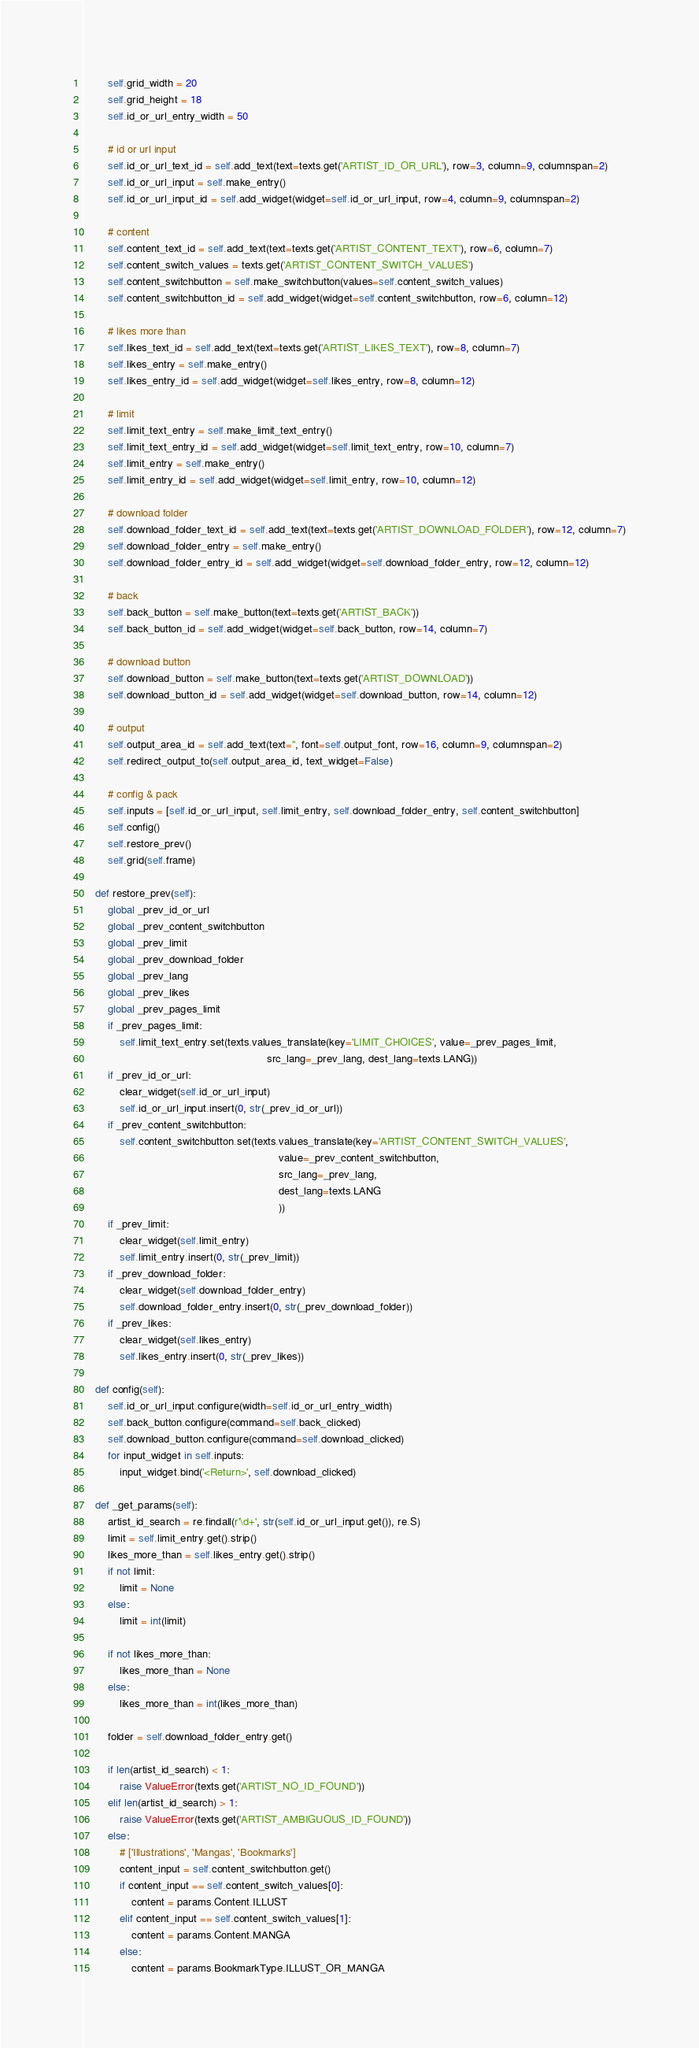<code> <loc_0><loc_0><loc_500><loc_500><_Python_>        self.grid_width = 20
        self.grid_height = 18
        self.id_or_url_entry_width = 50

        # id or url input
        self.id_or_url_text_id = self.add_text(text=texts.get('ARTIST_ID_OR_URL'), row=3, column=9, columnspan=2)
        self.id_or_url_input = self.make_entry()
        self.id_or_url_input_id = self.add_widget(widget=self.id_or_url_input, row=4, column=9, columnspan=2)

        # content
        self.content_text_id = self.add_text(text=texts.get('ARTIST_CONTENT_TEXT'), row=6, column=7)
        self.content_switch_values = texts.get('ARTIST_CONTENT_SWITCH_VALUES')
        self.content_switchbutton = self.make_switchbutton(values=self.content_switch_values)
        self.content_switchbutton_id = self.add_widget(widget=self.content_switchbutton, row=6, column=12)

        # likes more than
        self.likes_text_id = self.add_text(text=texts.get('ARTIST_LIKES_TEXT'), row=8, column=7)
        self.likes_entry = self.make_entry()
        self.likes_entry_id = self.add_widget(widget=self.likes_entry, row=8, column=12)

        # limit
        self.limit_text_entry = self.make_limit_text_entry()
        self.limit_text_entry_id = self.add_widget(widget=self.limit_text_entry, row=10, column=7)
        self.limit_entry = self.make_entry()
        self.limit_entry_id = self.add_widget(widget=self.limit_entry, row=10, column=12)

        # download folder
        self.download_folder_text_id = self.add_text(text=texts.get('ARTIST_DOWNLOAD_FOLDER'), row=12, column=7)
        self.download_folder_entry = self.make_entry()
        self.download_folder_entry_id = self.add_widget(widget=self.download_folder_entry, row=12, column=12)

        # back
        self.back_button = self.make_button(text=texts.get('ARTIST_BACK'))
        self.back_button_id = self.add_widget(widget=self.back_button, row=14, column=7)

        # download button
        self.download_button = self.make_button(text=texts.get('ARTIST_DOWNLOAD'))
        self.download_button_id = self.add_widget(widget=self.download_button, row=14, column=12)

        # output
        self.output_area_id = self.add_text(text='', font=self.output_font, row=16, column=9, columnspan=2)
        self.redirect_output_to(self.output_area_id, text_widget=False)

        # config & pack
        self.inputs = [self.id_or_url_input, self.limit_entry, self.download_folder_entry, self.content_switchbutton]
        self.config()
        self.restore_prev()
        self.grid(self.frame)

    def restore_prev(self):
        global _prev_id_or_url
        global _prev_content_switchbutton
        global _prev_limit
        global _prev_download_folder
        global _prev_lang
        global _prev_likes
        global _prev_pages_limit
        if _prev_pages_limit:
            self.limit_text_entry.set(texts.values_translate(key='LIMIT_CHOICES', value=_prev_pages_limit,
                                                             src_lang=_prev_lang, dest_lang=texts.LANG))
        if _prev_id_or_url:
            clear_widget(self.id_or_url_input)
            self.id_or_url_input.insert(0, str(_prev_id_or_url))
        if _prev_content_switchbutton:
            self.content_switchbutton.set(texts.values_translate(key='ARTIST_CONTENT_SWITCH_VALUES',
                                                                 value=_prev_content_switchbutton,
                                                                 src_lang=_prev_lang,
                                                                 dest_lang=texts.LANG
                                                                 ))
        if _prev_limit:
            clear_widget(self.limit_entry)
            self.limit_entry.insert(0, str(_prev_limit))
        if _prev_download_folder:
            clear_widget(self.download_folder_entry)
            self.download_folder_entry.insert(0, str(_prev_download_folder))
        if _prev_likes:
            clear_widget(self.likes_entry)
            self.likes_entry.insert(0, str(_prev_likes))

    def config(self):
        self.id_or_url_input.configure(width=self.id_or_url_entry_width)
        self.back_button.configure(command=self.back_clicked)
        self.download_button.configure(command=self.download_clicked)
        for input_widget in self.inputs:
            input_widget.bind('<Return>', self.download_clicked)

    def _get_params(self):
        artist_id_search = re.findall(r'\d+', str(self.id_or_url_input.get()), re.S)
        limit = self.limit_entry.get().strip()
        likes_more_than = self.likes_entry.get().strip()
        if not limit:
            limit = None
        else:
            limit = int(limit)

        if not likes_more_than:
            likes_more_than = None
        else:
            likes_more_than = int(likes_more_than)

        folder = self.download_folder_entry.get()

        if len(artist_id_search) < 1:
            raise ValueError(texts.get('ARTIST_NO_ID_FOUND'))
        elif len(artist_id_search) > 1:
            raise ValueError(texts.get('ARTIST_AMBIGUOUS_ID_FOUND'))
        else:
            # ['Illustrations', 'Mangas', 'Bookmarks']
            content_input = self.content_switchbutton.get()
            if content_input == self.content_switch_values[0]:
                content = params.Content.ILLUST
            elif content_input == self.content_switch_values[1]:
                content = params.Content.MANGA
            else:
                content = params.BookmarkType.ILLUST_OR_MANGA
</code> 